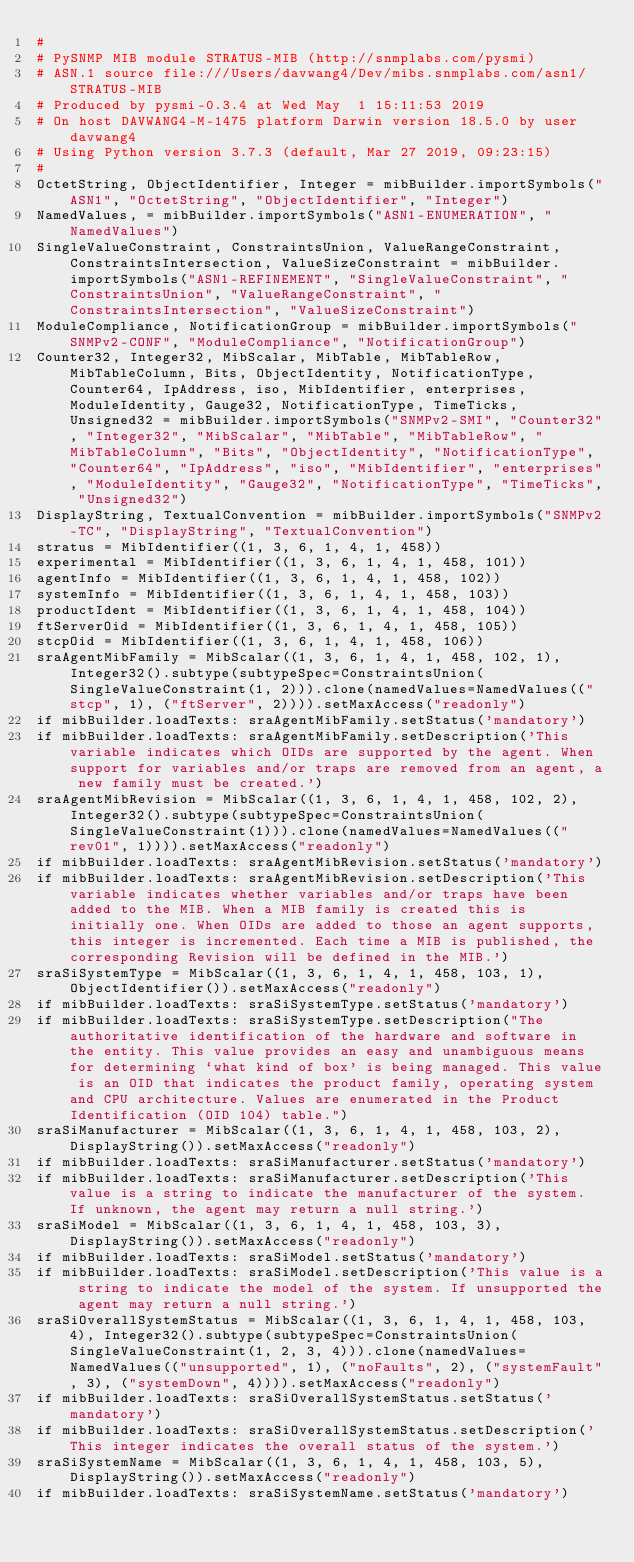Convert code to text. <code><loc_0><loc_0><loc_500><loc_500><_Python_>#
# PySNMP MIB module STRATUS-MIB (http://snmplabs.com/pysmi)
# ASN.1 source file:///Users/davwang4/Dev/mibs.snmplabs.com/asn1/STRATUS-MIB
# Produced by pysmi-0.3.4 at Wed May  1 15:11:53 2019
# On host DAVWANG4-M-1475 platform Darwin version 18.5.0 by user davwang4
# Using Python version 3.7.3 (default, Mar 27 2019, 09:23:15) 
#
OctetString, ObjectIdentifier, Integer = mibBuilder.importSymbols("ASN1", "OctetString", "ObjectIdentifier", "Integer")
NamedValues, = mibBuilder.importSymbols("ASN1-ENUMERATION", "NamedValues")
SingleValueConstraint, ConstraintsUnion, ValueRangeConstraint, ConstraintsIntersection, ValueSizeConstraint = mibBuilder.importSymbols("ASN1-REFINEMENT", "SingleValueConstraint", "ConstraintsUnion", "ValueRangeConstraint", "ConstraintsIntersection", "ValueSizeConstraint")
ModuleCompliance, NotificationGroup = mibBuilder.importSymbols("SNMPv2-CONF", "ModuleCompliance", "NotificationGroup")
Counter32, Integer32, MibScalar, MibTable, MibTableRow, MibTableColumn, Bits, ObjectIdentity, NotificationType, Counter64, IpAddress, iso, MibIdentifier, enterprises, ModuleIdentity, Gauge32, NotificationType, TimeTicks, Unsigned32 = mibBuilder.importSymbols("SNMPv2-SMI", "Counter32", "Integer32", "MibScalar", "MibTable", "MibTableRow", "MibTableColumn", "Bits", "ObjectIdentity", "NotificationType", "Counter64", "IpAddress", "iso", "MibIdentifier", "enterprises", "ModuleIdentity", "Gauge32", "NotificationType", "TimeTicks", "Unsigned32")
DisplayString, TextualConvention = mibBuilder.importSymbols("SNMPv2-TC", "DisplayString", "TextualConvention")
stratus = MibIdentifier((1, 3, 6, 1, 4, 1, 458))
experimental = MibIdentifier((1, 3, 6, 1, 4, 1, 458, 101))
agentInfo = MibIdentifier((1, 3, 6, 1, 4, 1, 458, 102))
systemInfo = MibIdentifier((1, 3, 6, 1, 4, 1, 458, 103))
productIdent = MibIdentifier((1, 3, 6, 1, 4, 1, 458, 104))
ftServerOid = MibIdentifier((1, 3, 6, 1, 4, 1, 458, 105))
stcpOid = MibIdentifier((1, 3, 6, 1, 4, 1, 458, 106))
sraAgentMibFamily = MibScalar((1, 3, 6, 1, 4, 1, 458, 102, 1), Integer32().subtype(subtypeSpec=ConstraintsUnion(SingleValueConstraint(1, 2))).clone(namedValues=NamedValues(("stcp", 1), ("ftServer", 2)))).setMaxAccess("readonly")
if mibBuilder.loadTexts: sraAgentMibFamily.setStatus('mandatory')
if mibBuilder.loadTexts: sraAgentMibFamily.setDescription('This variable indicates which OIDs are supported by the agent. When support for variables and/or traps are removed from an agent, a new family must be created.')
sraAgentMibRevision = MibScalar((1, 3, 6, 1, 4, 1, 458, 102, 2), Integer32().subtype(subtypeSpec=ConstraintsUnion(SingleValueConstraint(1))).clone(namedValues=NamedValues(("rev01", 1)))).setMaxAccess("readonly")
if mibBuilder.loadTexts: sraAgentMibRevision.setStatus('mandatory')
if mibBuilder.loadTexts: sraAgentMibRevision.setDescription('This variable indicates whether variables and/or traps have been added to the MIB. When a MIB family is created this is initially one. When OIDs are added to those an agent supports, this integer is incremented. Each time a MIB is published, the corresponding Revision will be defined in the MIB.')
sraSiSystemType = MibScalar((1, 3, 6, 1, 4, 1, 458, 103, 1), ObjectIdentifier()).setMaxAccess("readonly")
if mibBuilder.loadTexts: sraSiSystemType.setStatus('mandatory')
if mibBuilder.loadTexts: sraSiSystemType.setDescription("The authoritative identification of the hardware and software in the entity. This value provides an easy and unambiguous means for determining `what kind of box' is being managed. This value is an OID that indicates the product family, operating system and CPU architecture. Values are enumerated in the Product Identification (OID 104) table.")
sraSiManufacturer = MibScalar((1, 3, 6, 1, 4, 1, 458, 103, 2), DisplayString()).setMaxAccess("readonly")
if mibBuilder.loadTexts: sraSiManufacturer.setStatus('mandatory')
if mibBuilder.loadTexts: sraSiManufacturer.setDescription('This value is a string to indicate the manufacturer of the system. If unknown, the agent may return a null string.')
sraSiModel = MibScalar((1, 3, 6, 1, 4, 1, 458, 103, 3), DisplayString()).setMaxAccess("readonly")
if mibBuilder.loadTexts: sraSiModel.setStatus('mandatory')
if mibBuilder.loadTexts: sraSiModel.setDescription('This value is a string to indicate the model of the system. If unsupported the agent may return a null string.')
sraSiOverallSystemStatus = MibScalar((1, 3, 6, 1, 4, 1, 458, 103, 4), Integer32().subtype(subtypeSpec=ConstraintsUnion(SingleValueConstraint(1, 2, 3, 4))).clone(namedValues=NamedValues(("unsupported", 1), ("noFaults", 2), ("systemFault", 3), ("systemDown", 4)))).setMaxAccess("readonly")
if mibBuilder.loadTexts: sraSiOverallSystemStatus.setStatus('mandatory')
if mibBuilder.loadTexts: sraSiOverallSystemStatus.setDescription('This integer indicates the overall status of the system.')
sraSiSystemName = MibScalar((1, 3, 6, 1, 4, 1, 458, 103, 5), DisplayString()).setMaxAccess("readonly")
if mibBuilder.loadTexts: sraSiSystemName.setStatus('mandatory')</code> 